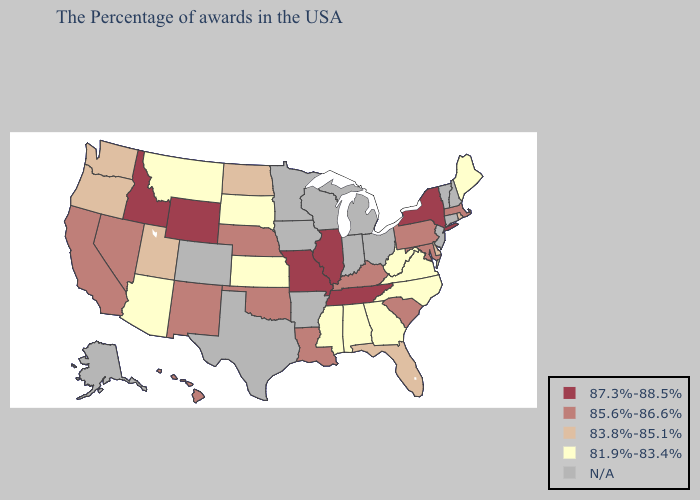Among the states that border Oklahoma , does Kansas have the lowest value?
Quick response, please. Yes. What is the highest value in states that border Tennessee?
Concise answer only. 87.3%-88.5%. Which states have the lowest value in the South?
Write a very short answer. Virginia, North Carolina, West Virginia, Georgia, Alabama, Mississippi. Name the states that have a value in the range N/A?
Give a very brief answer. New Hampshire, Vermont, Connecticut, New Jersey, Ohio, Michigan, Indiana, Wisconsin, Arkansas, Minnesota, Iowa, Texas, Colorado, Alaska. What is the value of Iowa?
Write a very short answer. N/A. Does Georgia have the highest value in the South?
Short answer required. No. What is the highest value in states that border Mississippi?
Answer briefly. 87.3%-88.5%. Name the states that have a value in the range 85.6%-86.6%?
Short answer required. Massachusetts, Maryland, Pennsylvania, South Carolina, Kentucky, Louisiana, Nebraska, Oklahoma, New Mexico, Nevada, California, Hawaii. Name the states that have a value in the range 85.6%-86.6%?
Answer briefly. Massachusetts, Maryland, Pennsylvania, South Carolina, Kentucky, Louisiana, Nebraska, Oklahoma, New Mexico, Nevada, California, Hawaii. What is the highest value in states that border Texas?
Write a very short answer. 85.6%-86.6%. How many symbols are there in the legend?
Short answer required. 5. What is the value of Kansas?
Answer briefly. 81.9%-83.4%. Name the states that have a value in the range N/A?
Be succinct. New Hampshire, Vermont, Connecticut, New Jersey, Ohio, Michigan, Indiana, Wisconsin, Arkansas, Minnesota, Iowa, Texas, Colorado, Alaska. What is the value of Nebraska?
Keep it brief. 85.6%-86.6%. 